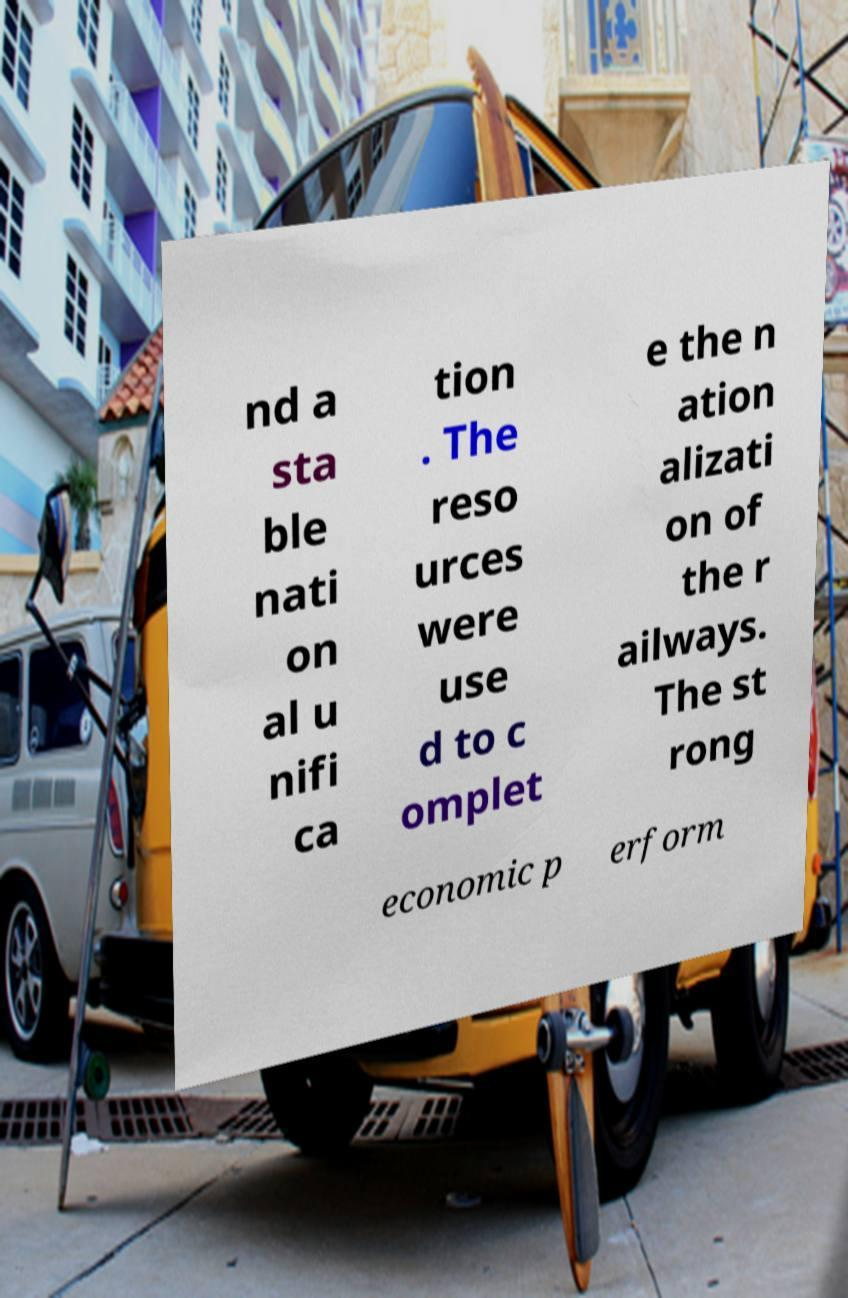Could you extract and type out the text from this image? nd a sta ble nati on al u nifi ca tion . The reso urces were use d to c omplet e the n ation alizati on of the r ailways. The st rong economic p erform 